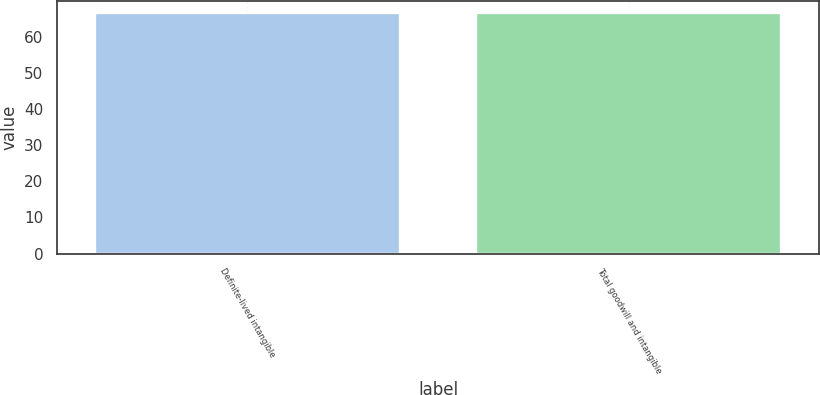Convert chart to OTSL. <chart><loc_0><loc_0><loc_500><loc_500><bar_chart><fcel>Definite-lived intangible<fcel>Total goodwill and intangible<nl><fcel>66.5<fcel>66.6<nl></chart> 